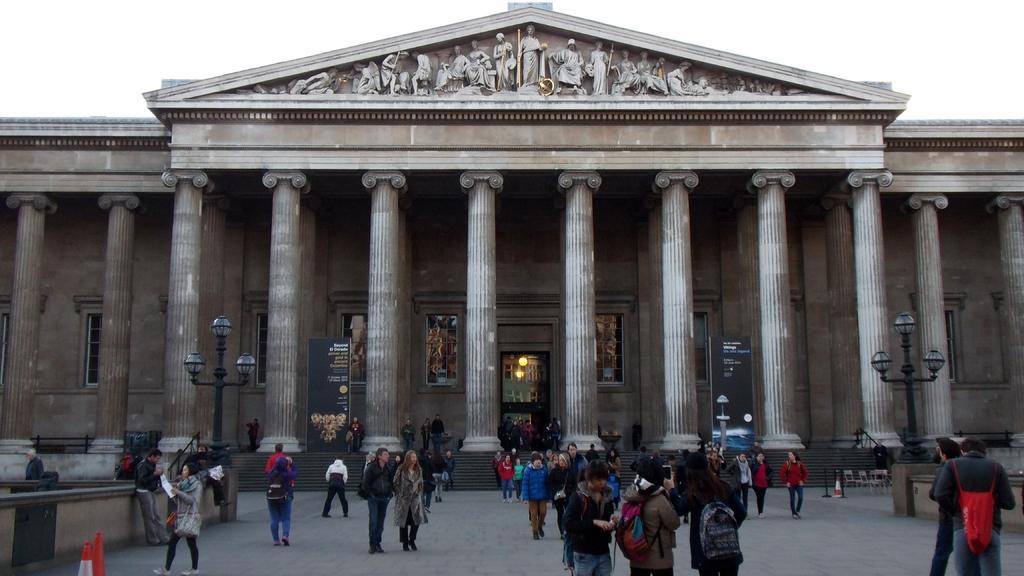Please provide a concise description of this image. In this picture I can observe some people walking on the land. There are men and women in this picture. On the left side I can observe traffic cones. In the background there is a building. I can observe some pillars in front of this building. There are some carvings on the top of the building. In the background there is a sky. 